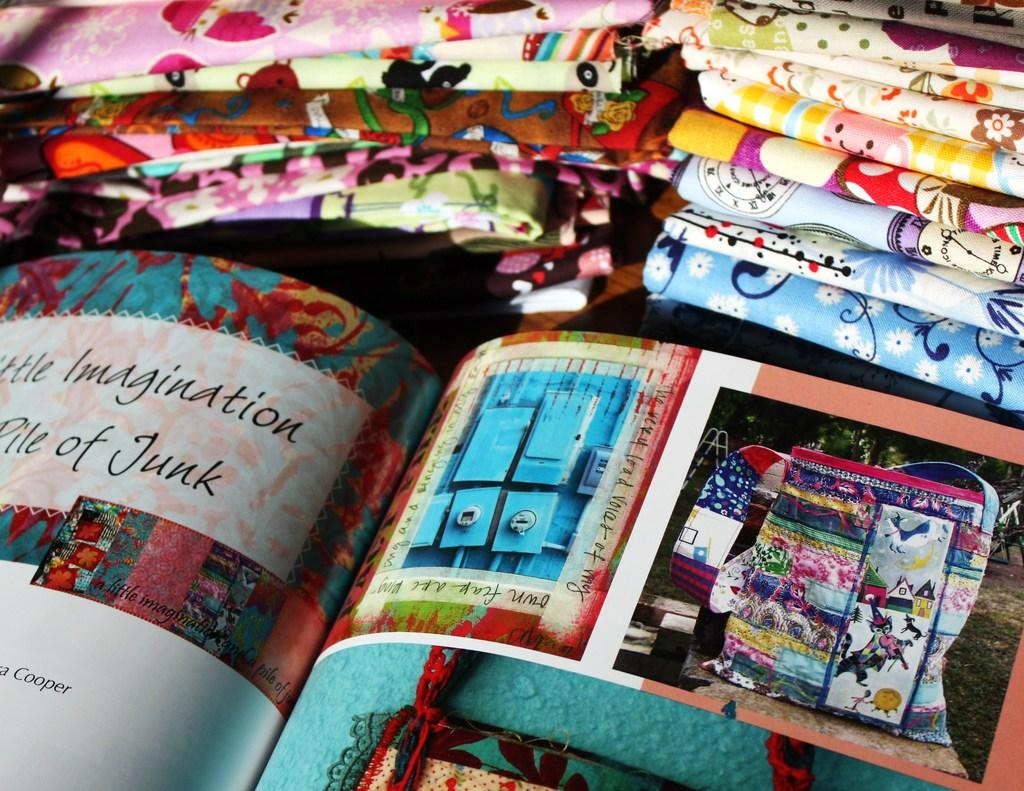Provide a one-sentence caption for the provided image. a book next to fabric that says 'imagination pile of junk' on it. 